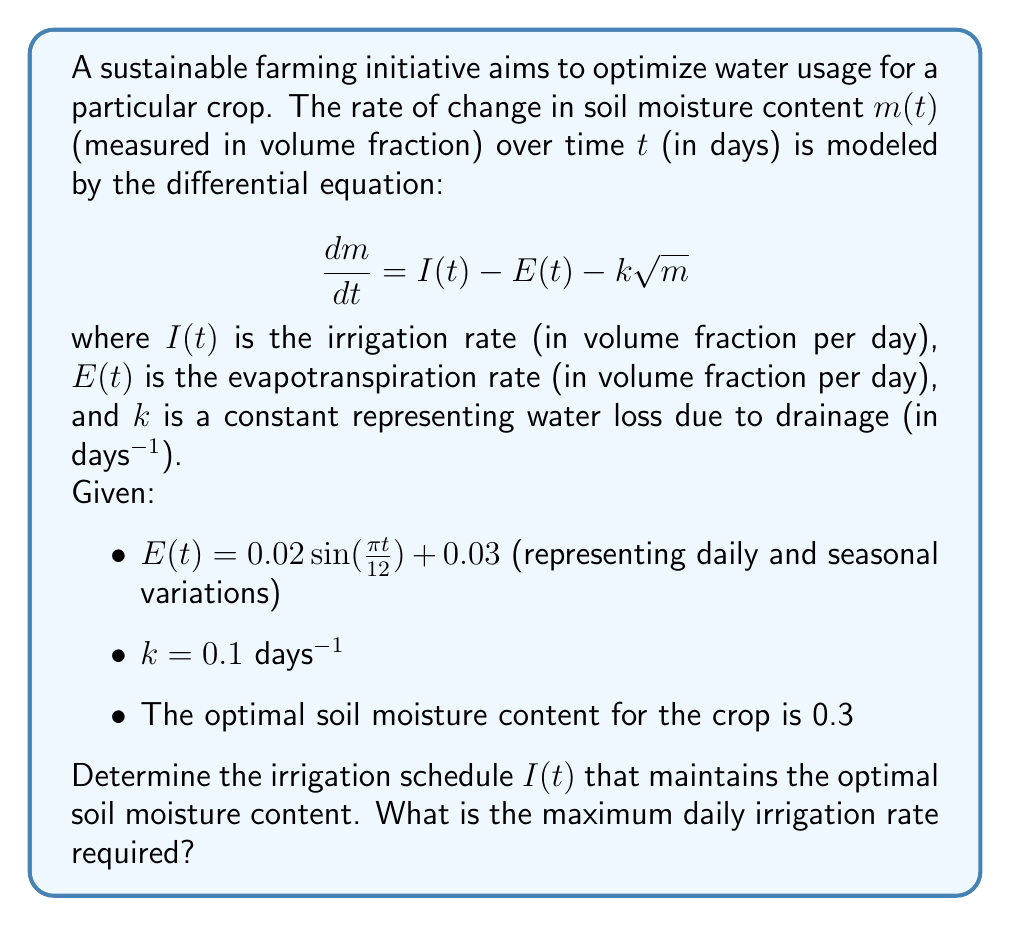Could you help me with this problem? To solve this problem, we need to follow these steps:

1) Since we want to maintain a constant optimal soil moisture content, we set $\frac{dm}{dt} = 0$ and $m = 0.3$.

2) Substituting these values into the original differential equation:

   $$0 = I(t) - E(t) - k\sqrt{m}$$

3) Rearranging to solve for $I(t)$:

   $$I(t) = E(t) + k\sqrt{m}$$

4) Now, let's substitute the known values:

   $$I(t) = [0.02 \sin(\frac{\pi t}{12}) + 0.03] + 0.1\sqrt{0.3}$$

5) Simplify:

   $$I(t) = 0.02 \sin(\frac{\pi t}{12}) + 0.03 + 0.1 \cdot 0.5477$$
   $$I(t) = 0.02 \sin(\frac{\pi t}{12}) + 0.03 + 0.05477$$
   $$I(t) = 0.02 \sin(\frac{\pi t}{12}) + 0.08477$$

6) This equation represents the irrigation schedule that maintains the optimal soil moisture content.

7) To find the maximum daily irrigation rate, we need to find the maximum value of this function. The maximum occurs when $\sin(\frac{\pi t}{12})$ is at its peak value of 1.

   $$I_{max} = 0.02 \cdot 1 + 0.08477 = 0.10477$$
Answer: The optimal irrigation schedule is given by $I(t) = 0.02 \sin(\frac{\pi t}{12}) + 0.08477$ volume fraction per day. The maximum daily irrigation rate required is 0.10477 volume fraction per day. 